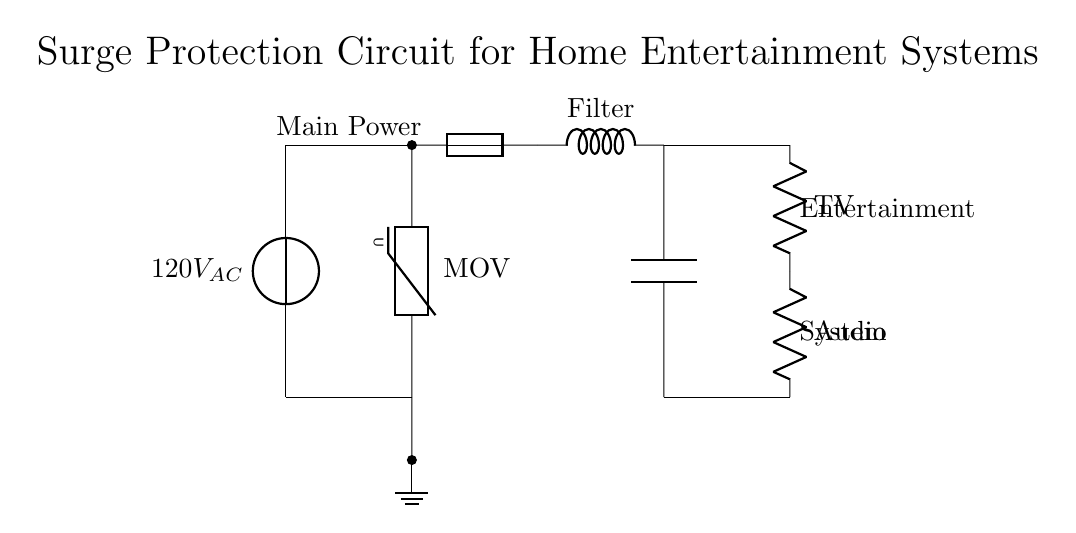What is the voltage of this circuit? The voltage source is labeled as 120V AC, indicating the potential difference supplied to the circuit.
Answer: 120V AC What component is used for surge protection? The component labeled as MOV in the diagram is a Metal Oxide Varistor, which is commonly used for surge protection in circuits.
Answer: MOV How many resistive loads are connected to the circuit? There are two resistive loads, a TV and an Audio system, which are both indicated as resistors (R) in the diagram.
Answer: Two What is the purpose of the fuse in this circuit? The fuse is used to protect the circuit from excessive current, acting as a safety device that will disconnect the circuit if the current exceeds a certain limit.
Answer: To protect from excessive current Explain the flow of current through the surge protection circuit. The current flows from the voltage source at 120V AC to the MOV for surge protection. If no surge is detected, it proceeds through the fuse and filters before reaching the resistive loads (TV and Audio) connected at the output. The current has a designated path, ensuring that it is conditioned for safe use by the appliances.
Answer: Current flows from source to MOV, then fuse, filters, ending at loads What does the filter in this circuit do? The filter, indicated in the diagram, is designed to remove unwanted high-frequency noise and transients from the power supply before it reaches connected devices, ensuring cleaner power delivery.
Answer: To remove high-frequency noise What connects the power source to the ground in this circuit? The ground connection is indicated at the bottom of the circuit, where there is a line connecting the MOV to the ground symbol, ensuring that excess voltage can safely dissipate to the ground.
Answer: The MOV connects to ground 